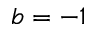Convert formula to latex. <formula><loc_0><loc_0><loc_500><loc_500>b = - 1</formula> 